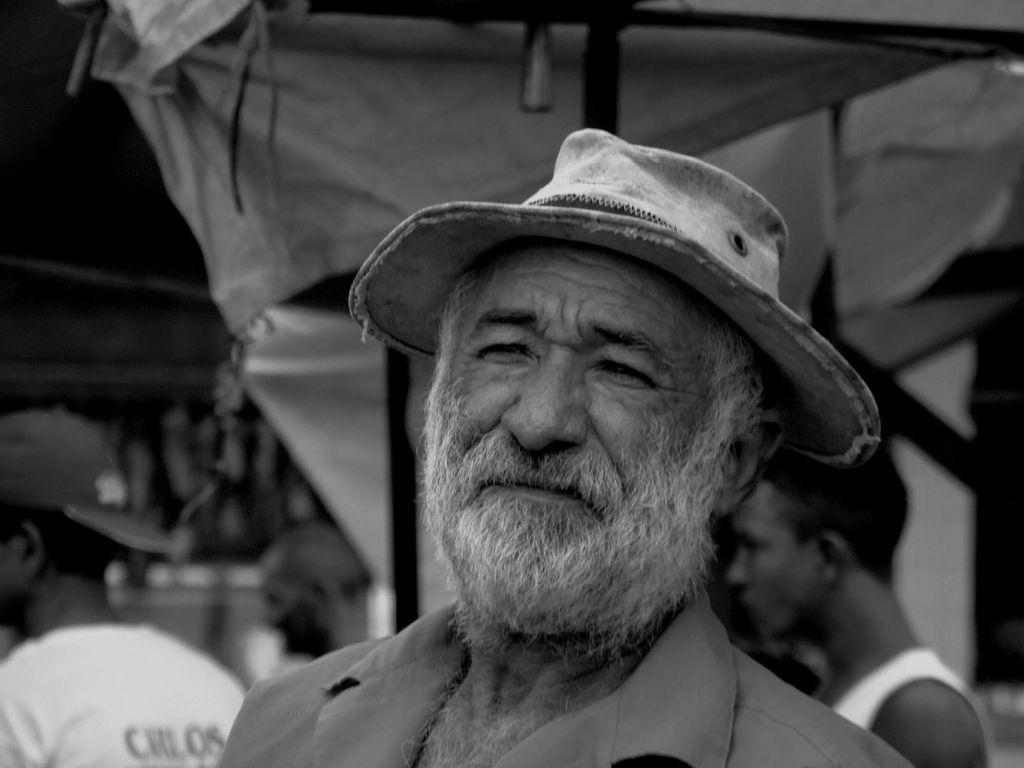In one or two sentences, can you explain what this image depicts? This is the black and white image and we can see a man wearing a cap in the middle of the image and there are few people. In the background, the image is blurred. 